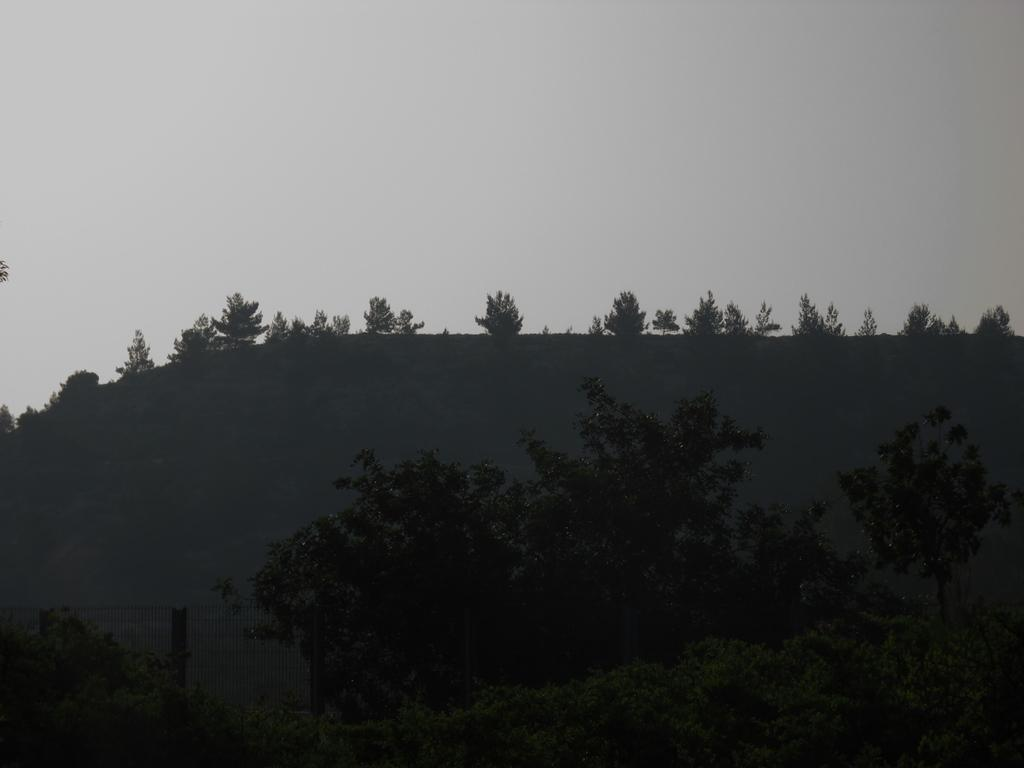What type of vegetation can be seen in the image? There are trees in the image. What structures are present in the image? There are poles in the image. What else can be seen connecting the poles? There are wires in the image. How would you describe the lighting in the image? The image appears to be slightly dark. What type of stew is being cooked on the poles in the image? There is no stew or cooking activity present in the image; it features trees, poles, and wires. Can you tell me how many ears are visible on the trees in the image? There are no ears present in the image; it features trees, poles, and wires. 